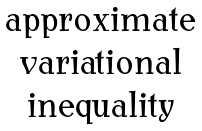Convert formula to latex. <formula><loc_0><loc_0><loc_500><loc_500>\begin{matrix} \text { approximate} \\ \text { variational} \\ \text { inequality} \end{matrix}</formula> 